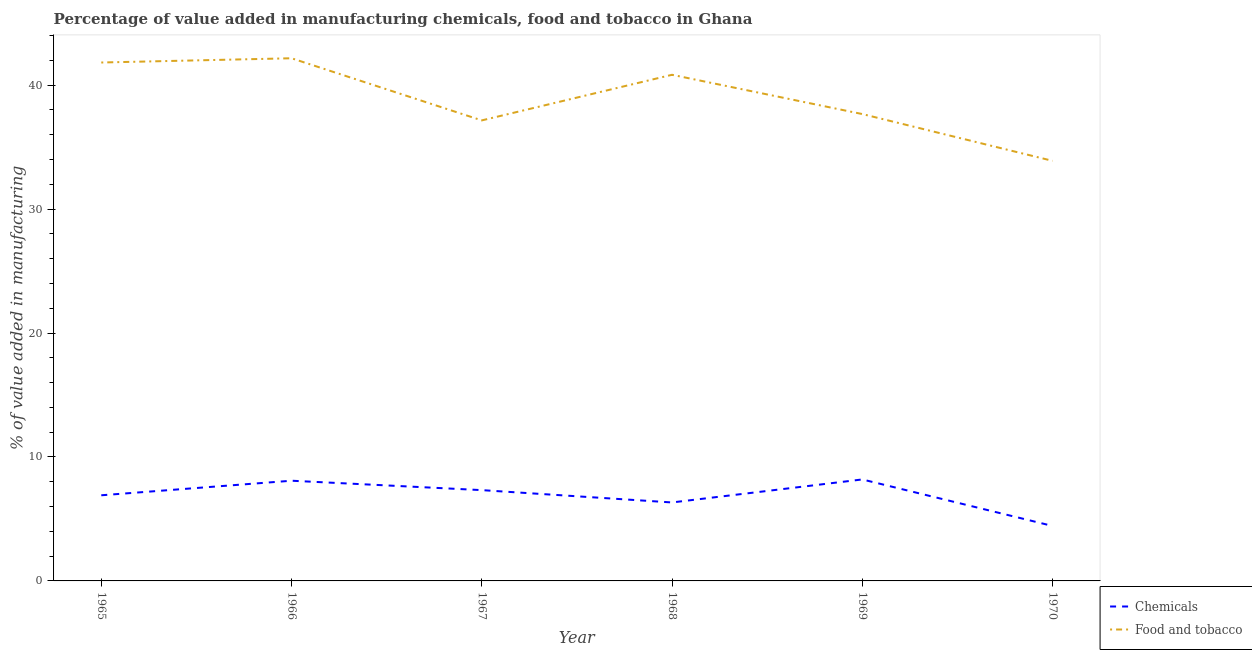Does the line corresponding to value added by  manufacturing chemicals intersect with the line corresponding to value added by manufacturing food and tobacco?
Your answer should be very brief. No. What is the value added by manufacturing food and tobacco in 1970?
Offer a terse response. 33.89. Across all years, what is the maximum value added by  manufacturing chemicals?
Provide a short and direct response. 8.19. Across all years, what is the minimum value added by  manufacturing chemicals?
Make the answer very short. 4.43. In which year was the value added by manufacturing food and tobacco maximum?
Offer a very short reply. 1966. What is the total value added by  manufacturing chemicals in the graph?
Provide a short and direct response. 41.27. What is the difference between the value added by manufacturing food and tobacco in 1969 and that in 1970?
Keep it short and to the point. 3.77. What is the difference between the value added by  manufacturing chemicals in 1966 and the value added by manufacturing food and tobacco in 1967?
Provide a succinct answer. -29.07. What is the average value added by  manufacturing chemicals per year?
Your answer should be compact. 6.88. In the year 1965, what is the difference between the value added by  manufacturing chemicals and value added by manufacturing food and tobacco?
Your response must be concise. -34.91. What is the ratio of the value added by manufacturing food and tobacco in 1969 to that in 1970?
Give a very brief answer. 1.11. Is the value added by manufacturing food and tobacco in 1967 less than that in 1968?
Your answer should be very brief. Yes. Is the difference between the value added by  manufacturing chemicals in 1965 and 1968 greater than the difference between the value added by manufacturing food and tobacco in 1965 and 1968?
Your response must be concise. No. What is the difference between the highest and the second highest value added by manufacturing food and tobacco?
Ensure brevity in your answer.  0.34. What is the difference between the highest and the lowest value added by manufacturing food and tobacco?
Ensure brevity in your answer.  8.28. Is the sum of the value added by manufacturing food and tobacco in 1965 and 1968 greater than the maximum value added by  manufacturing chemicals across all years?
Give a very brief answer. Yes. Does the value added by manufacturing food and tobacco monotonically increase over the years?
Your answer should be compact. No. Is the value added by manufacturing food and tobacco strictly greater than the value added by  manufacturing chemicals over the years?
Your response must be concise. Yes. How many years are there in the graph?
Provide a succinct answer. 6. How many legend labels are there?
Offer a terse response. 2. How are the legend labels stacked?
Make the answer very short. Vertical. What is the title of the graph?
Provide a succinct answer. Percentage of value added in manufacturing chemicals, food and tobacco in Ghana. Does "Non-solid fuel" appear as one of the legend labels in the graph?
Make the answer very short. No. What is the label or title of the X-axis?
Give a very brief answer. Year. What is the label or title of the Y-axis?
Give a very brief answer. % of value added in manufacturing. What is the % of value added in manufacturing of Chemicals in 1965?
Your answer should be compact. 6.91. What is the % of value added in manufacturing in Food and tobacco in 1965?
Give a very brief answer. 41.82. What is the % of value added in manufacturing in Chemicals in 1966?
Your response must be concise. 8.08. What is the % of value added in manufacturing in Food and tobacco in 1966?
Ensure brevity in your answer.  42.16. What is the % of value added in manufacturing in Chemicals in 1967?
Provide a short and direct response. 7.32. What is the % of value added in manufacturing of Food and tobacco in 1967?
Keep it short and to the point. 37.15. What is the % of value added in manufacturing of Chemicals in 1968?
Provide a short and direct response. 6.33. What is the % of value added in manufacturing of Food and tobacco in 1968?
Provide a succinct answer. 40.83. What is the % of value added in manufacturing in Chemicals in 1969?
Offer a terse response. 8.19. What is the % of value added in manufacturing of Food and tobacco in 1969?
Offer a terse response. 37.66. What is the % of value added in manufacturing in Chemicals in 1970?
Provide a short and direct response. 4.43. What is the % of value added in manufacturing in Food and tobacco in 1970?
Offer a very short reply. 33.89. Across all years, what is the maximum % of value added in manufacturing of Chemicals?
Your answer should be very brief. 8.19. Across all years, what is the maximum % of value added in manufacturing in Food and tobacco?
Provide a short and direct response. 42.16. Across all years, what is the minimum % of value added in manufacturing in Chemicals?
Provide a short and direct response. 4.43. Across all years, what is the minimum % of value added in manufacturing of Food and tobacco?
Keep it short and to the point. 33.89. What is the total % of value added in manufacturing of Chemicals in the graph?
Provide a succinct answer. 41.27. What is the total % of value added in manufacturing in Food and tobacco in the graph?
Your answer should be very brief. 233.52. What is the difference between the % of value added in manufacturing of Chemicals in 1965 and that in 1966?
Ensure brevity in your answer.  -1.17. What is the difference between the % of value added in manufacturing in Food and tobacco in 1965 and that in 1966?
Give a very brief answer. -0.34. What is the difference between the % of value added in manufacturing of Chemicals in 1965 and that in 1967?
Ensure brevity in your answer.  -0.42. What is the difference between the % of value added in manufacturing of Food and tobacco in 1965 and that in 1967?
Provide a succinct answer. 4.67. What is the difference between the % of value added in manufacturing of Chemicals in 1965 and that in 1968?
Provide a short and direct response. 0.58. What is the difference between the % of value added in manufacturing of Chemicals in 1965 and that in 1969?
Provide a succinct answer. -1.28. What is the difference between the % of value added in manufacturing of Food and tobacco in 1965 and that in 1969?
Your answer should be compact. 4.16. What is the difference between the % of value added in manufacturing in Chemicals in 1965 and that in 1970?
Your response must be concise. 2.47. What is the difference between the % of value added in manufacturing of Food and tobacco in 1965 and that in 1970?
Offer a terse response. 7.93. What is the difference between the % of value added in manufacturing of Chemicals in 1966 and that in 1967?
Give a very brief answer. 0.76. What is the difference between the % of value added in manufacturing in Food and tobacco in 1966 and that in 1967?
Offer a very short reply. 5.01. What is the difference between the % of value added in manufacturing of Chemicals in 1966 and that in 1968?
Your response must be concise. 1.75. What is the difference between the % of value added in manufacturing of Food and tobacco in 1966 and that in 1968?
Your answer should be very brief. 1.33. What is the difference between the % of value added in manufacturing of Chemicals in 1966 and that in 1969?
Give a very brief answer. -0.1. What is the difference between the % of value added in manufacturing in Food and tobacco in 1966 and that in 1969?
Offer a very short reply. 4.5. What is the difference between the % of value added in manufacturing in Chemicals in 1966 and that in 1970?
Your response must be concise. 3.65. What is the difference between the % of value added in manufacturing of Food and tobacco in 1966 and that in 1970?
Ensure brevity in your answer.  8.28. What is the difference between the % of value added in manufacturing in Food and tobacco in 1967 and that in 1968?
Provide a succinct answer. -3.68. What is the difference between the % of value added in manufacturing of Chemicals in 1967 and that in 1969?
Your answer should be very brief. -0.86. What is the difference between the % of value added in manufacturing of Food and tobacco in 1967 and that in 1969?
Offer a very short reply. -0.51. What is the difference between the % of value added in manufacturing in Chemicals in 1967 and that in 1970?
Keep it short and to the point. 2.89. What is the difference between the % of value added in manufacturing in Food and tobacco in 1967 and that in 1970?
Give a very brief answer. 3.26. What is the difference between the % of value added in manufacturing of Chemicals in 1968 and that in 1969?
Offer a very short reply. -1.86. What is the difference between the % of value added in manufacturing in Food and tobacco in 1968 and that in 1969?
Provide a short and direct response. 3.17. What is the difference between the % of value added in manufacturing in Chemicals in 1968 and that in 1970?
Provide a short and direct response. 1.9. What is the difference between the % of value added in manufacturing in Food and tobacco in 1968 and that in 1970?
Make the answer very short. 6.94. What is the difference between the % of value added in manufacturing of Chemicals in 1969 and that in 1970?
Your response must be concise. 3.75. What is the difference between the % of value added in manufacturing in Food and tobacco in 1969 and that in 1970?
Your response must be concise. 3.77. What is the difference between the % of value added in manufacturing of Chemicals in 1965 and the % of value added in manufacturing of Food and tobacco in 1966?
Your response must be concise. -35.26. What is the difference between the % of value added in manufacturing of Chemicals in 1965 and the % of value added in manufacturing of Food and tobacco in 1967?
Your answer should be very brief. -30.24. What is the difference between the % of value added in manufacturing of Chemicals in 1965 and the % of value added in manufacturing of Food and tobacco in 1968?
Provide a short and direct response. -33.92. What is the difference between the % of value added in manufacturing of Chemicals in 1965 and the % of value added in manufacturing of Food and tobacco in 1969?
Your answer should be very brief. -30.75. What is the difference between the % of value added in manufacturing of Chemicals in 1965 and the % of value added in manufacturing of Food and tobacco in 1970?
Ensure brevity in your answer.  -26.98. What is the difference between the % of value added in manufacturing in Chemicals in 1966 and the % of value added in manufacturing in Food and tobacco in 1967?
Your response must be concise. -29.07. What is the difference between the % of value added in manufacturing in Chemicals in 1966 and the % of value added in manufacturing in Food and tobacco in 1968?
Provide a succinct answer. -32.75. What is the difference between the % of value added in manufacturing of Chemicals in 1966 and the % of value added in manufacturing of Food and tobacco in 1969?
Provide a succinct answer. -29.58. What is the difference between the % of value added in manufacturing of Chemicals in 1966 and the % of value added in manufacturing of Food and tobacco in 1970?
Offer a terse response. -25.81. What is the difference between the % of value added in manufacturing in Chemicals in 1967 and the % of value added in manufacturing in Food and tobacco in 1968?
Keep it short and to the point. -33.51. What is the difference between the % of value added in manufacturing of Chemicals in 1967 and the % of value added in manufacturing of Food and tobacco in 1969?
Provide a short and direct response. -30.34. What is the difference between the % of value added in manufacturing in Chemicals in 1967 and the % of value added in manufacturing in Food and tobacco in 1970?
Your answer should be compact. -26.56. What is the difference between the % of value added in manufacturing in Chemicals in 1968 and the % of value added in manufacturing in Food and tobacco in 1969?
Your answer should be very brief. -31.33. What is the difference between the % of value added in manufacturing in Chemicals in 1968 and the % of value added in manufacturing in Food and tobacco in 1970?
Provide a succinct answer. -27.56. What is the difference between the % of value added in manufacturing in Chemicals in 1969 and the % of value added in manufacturing in Food and tobacco in 1970?
Provide a short and direct response. -25.7. What is the average % of value added in manufacturing in Chemicals per year?
Your answer should be compact. 6.88. What is the average % of value added in manufacturing of Food and tobacco per year?
Your answer should be very brief. 38.92. In the year 1965, what is the difference between the % of value added in manufacturing of Chemicals and % of value added in manufacturing of Food and tobacco?
Your answer should be compact. -34.91. In the year 1966, what is the difference between the % of value added in manufacturing of Chemicals and % of value added in manufacturing of Food and tobacco?
Your answer should be compact. -34.08. In the year 1967, what is the difference between the % of value added in manufacturing in Chemicals and % of value added in manufacturing in Food and tobacco?
Keep it short and to the point. -29.83. In the year 1968, what is the difference between the % of value added in manufacturing in Chemicals and % of value added in manufacturing in Food and tobacco?
Provide a succinct answer. -34.5. In the year 1969, what is the difference between the % of value added in manufacturing of Chemicals and % of value added in manufacturing of Food and tobacco?
Provide a succinct answer. -29.48. In the year 1970, what is the difference between the % of value added in manufacturing of Chemicals and % of value added in manufacturing of Food and tobacco?
Ensure brevity in your answer.  -29.45. What is the ratio of the % of value added in manufacturing of Chemicals in 1965 to that in 1966?
Your answer should be compact. 0.85. What is the ratio of the % of value added in manufacturing of Food and tobacco in 1965 to that in 1966?
Your response must be concise. 0.99. What is the ratio of the % of value added in manufacturing in Chemicals in 1965 to that in 1967?
Provide a short and direct response. 0.94. What is the ratio of the % of value added in manufacturing in Food and tobacco in 1965 to that in 1967?
Offer a very short reply. 1.13. What is the ratio of the % of value added in manufacturing in Chemicals in 1965 to that in 1968?
Your response must be concise. 1.09. What is the ratio of the % of value added in manufacturing in Food and tobacco in 1965 to that in 1968?
Offer a terse response. 1.02. What is the ratio of the % of value added in manufacturing in Chemicals in 1965 to that in 1969?
Your answer should be compact. 0.84. What is the ratio of the % of value added in manufacturing of Food and tobacco in 1965 to that in 1969?
Ensure brevity in your answer.  1.11. What is the ratio of the % of value added in manufacturing of Chemicals in 1965 to that in 1970?
Your answer should be compact. 1.56. What is the ratio of the % of value added in manufacturing of Food and tobacco in 1965 to that in 1970?
Keep it short and to the point. 1.23. What is the ratio of the % of value added in manufacturing in Chemicals in 1966 to that in 1967?
Make the answer very short. 1.1. What is the ratio of the % of value added in manufacturing of Food and tobacco in 1966 to that in 1967?
Provide a short and direct response. 1.13. What is the ratio of the % of value added in manufacturing in Chemicals in 1966 to that in 1968?
Your answer should be compact. 1.28. What is the ratio of the % of value added in manufacturing of Food and tobacco in 1966 to that in 1968?
Your answer should be compact. 1.03. What is the ratio of the % of value added in manufacturing in Chemicals in 1966 to that in 1969?
Provide a short and direct response. 0.99. What is the ratio of the % of value added in manufacturing in Food and tobacco in 1966 to that in 1969?
Offer a terse response. 1.12. What is the ratio of the % of value added in manufacturing in Chemicals in 1966 to that in 1970?
Your answer should be compact. 1.82. What is the ratio of the % of value added in manufacturing of Food and tobacco in 1966 to that in 1970?
Offer a very short reply. 1.24. What is the ratio of the % of value added in manufacturing in Chemicals in 1967 to that in 1968?
Your answer should be very brief. 1.16. What is the ratio of the % of value added in manufacturing of Food and tobacco in 1967 to that in 1968?
Keep it short and to the point. 0.91. What is the ratio of the % of value added in manufacturing of Chemicals in 1967 to that in 1969?
Make the answer very short. 0.89. What is the ratio of the % of value added in manufacturing of Food and tobacco in 1967 to that in 1969?
Give a very brief answer. 0.99. What is the ratio of the % of value added in manufacturing in Chemicals in 1967 to that in 1970?
Provide a short and direct response. 1.65. What is the ratio of the % of value added in manufacturing in Food and tobacco in 1967 to that in 1970?
Your response must be concise. 1.1. What is the ratio of the % of value added in manufacturing of Chemicals in 1968 to that in 1969?
Your answer should be very brief. 0.77. What is the ratio of the % of value added in manufacturing of Food and tobacco in 1968 to that in 1969?
Offer a very short reply. 1.08. What is the ratio of the % of value added in manufacturing of Chemicals in 1968 to that in 1970?
Provide a short and direct response. 1.43. What is the ratio of the % of value added in manufacturing of Food and tobacco in 1968 to that in 1970?
Offer a very short reply. 1.2. What is the ratio of the % of value added in manufacturing of Chemicals in 1969 to that in 1970?
Your answer should be very brief. 1.85. What is the ratio of the % of value added in manufacturing in Food and tobacco in 1969 to that in 1970?
Provide a short and direct response. 1.11. What is the difference between the highest and the second highest % of value added in manufacturing of Chemicals?
Ensure brevity in your answer.  0.1. What is the difference between the highest and the second highest % of value added in manufacturing in Food and tobacco?
Give a very brief answer. 0.34. What is the difference between the highest and the lowest % of value added in manufacturing of Chemicals?
Ensure brevity in your answer.  3.75. What is the difference between the highest and the lowest % of value added in manufacturing in Food and tobacco?
Offer a terse response. 8.28. 